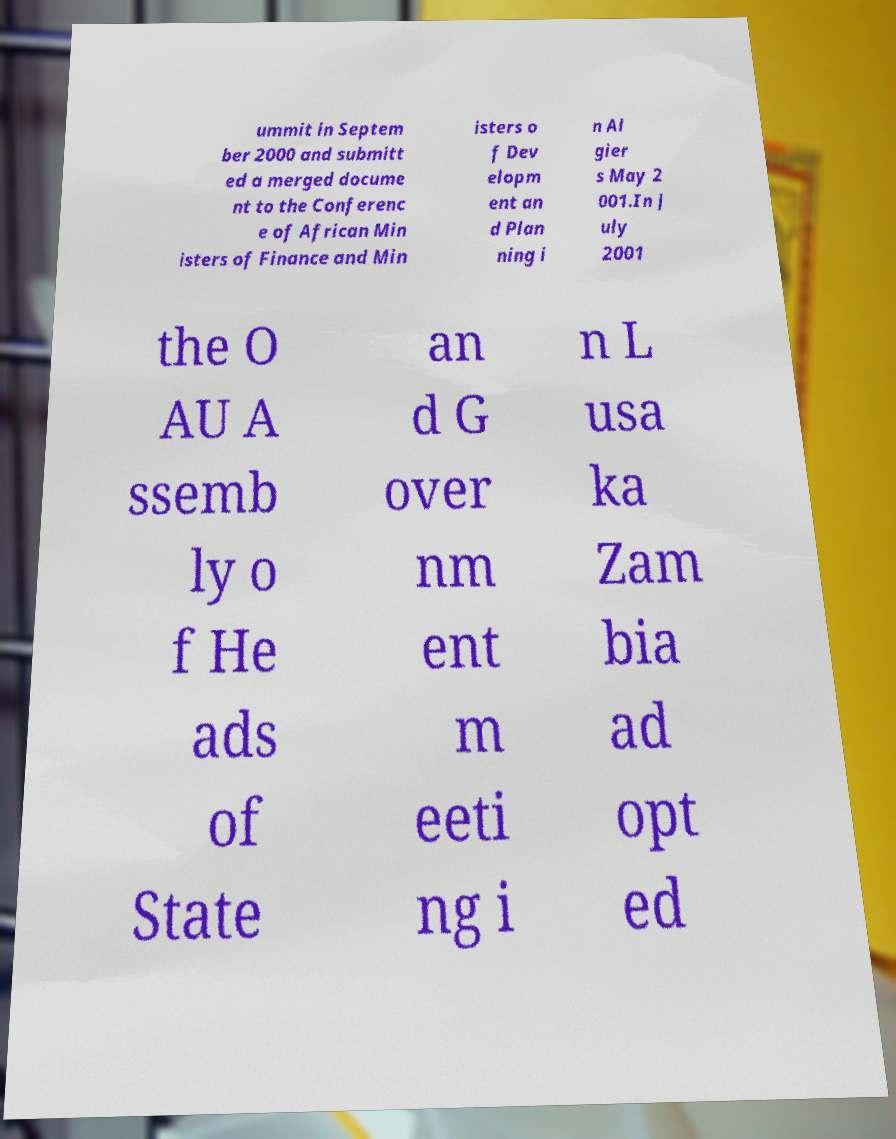What messages or text are displayed in this image? I need them in a readable, typed format. ummit in Septem ber 2000 and submitt ed a merged docume nt to the Conferenc e of African Min isters of Finance and Min isters o f Dev elopm ent an d Plan ning i n Al gier s May 2 001.In J uly 2001 the O AU A ssemb ly o f He ads of State an d G over nm ent m eeti ng i n L usa ka Zam bia ad opt ed 